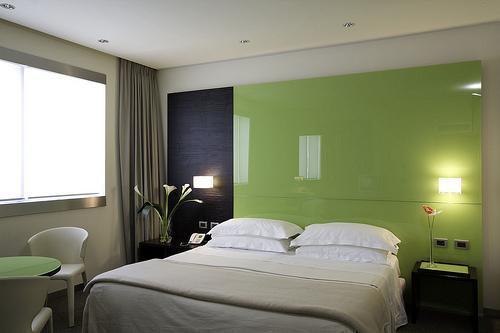How many red roses are there on the bed?
Give a very brief answer. 0. 